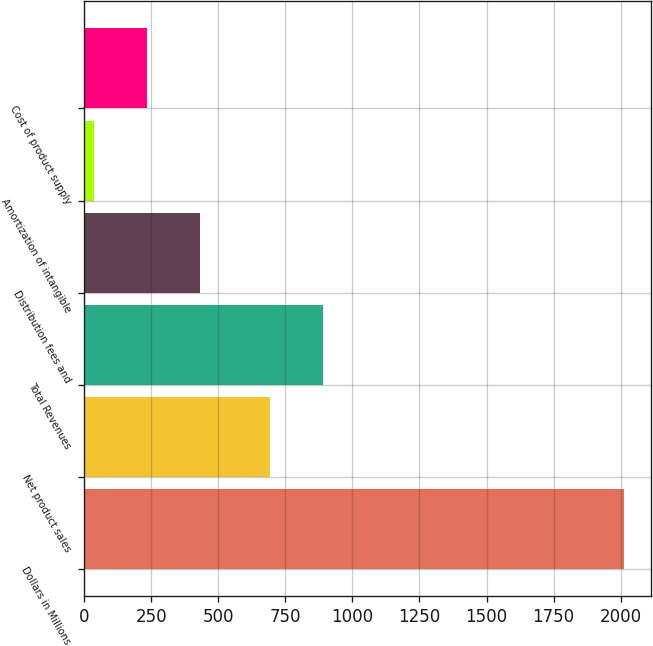Convert chart to OTSL. <chart><loc_0><loc_0><loc_500><loc_500><bar_chart><fcel>Dollars in Millions<fcel>Net product sales<fcel>Total Revenues<fcel>Distribution fees and<fcel>Amortization of intangible<fcel>Cost of product supply<nl><fcel>2014<fcel>691<fcel>888.7<fcel>432.4<fcel>37<fcel>234.7<nl></chart> 